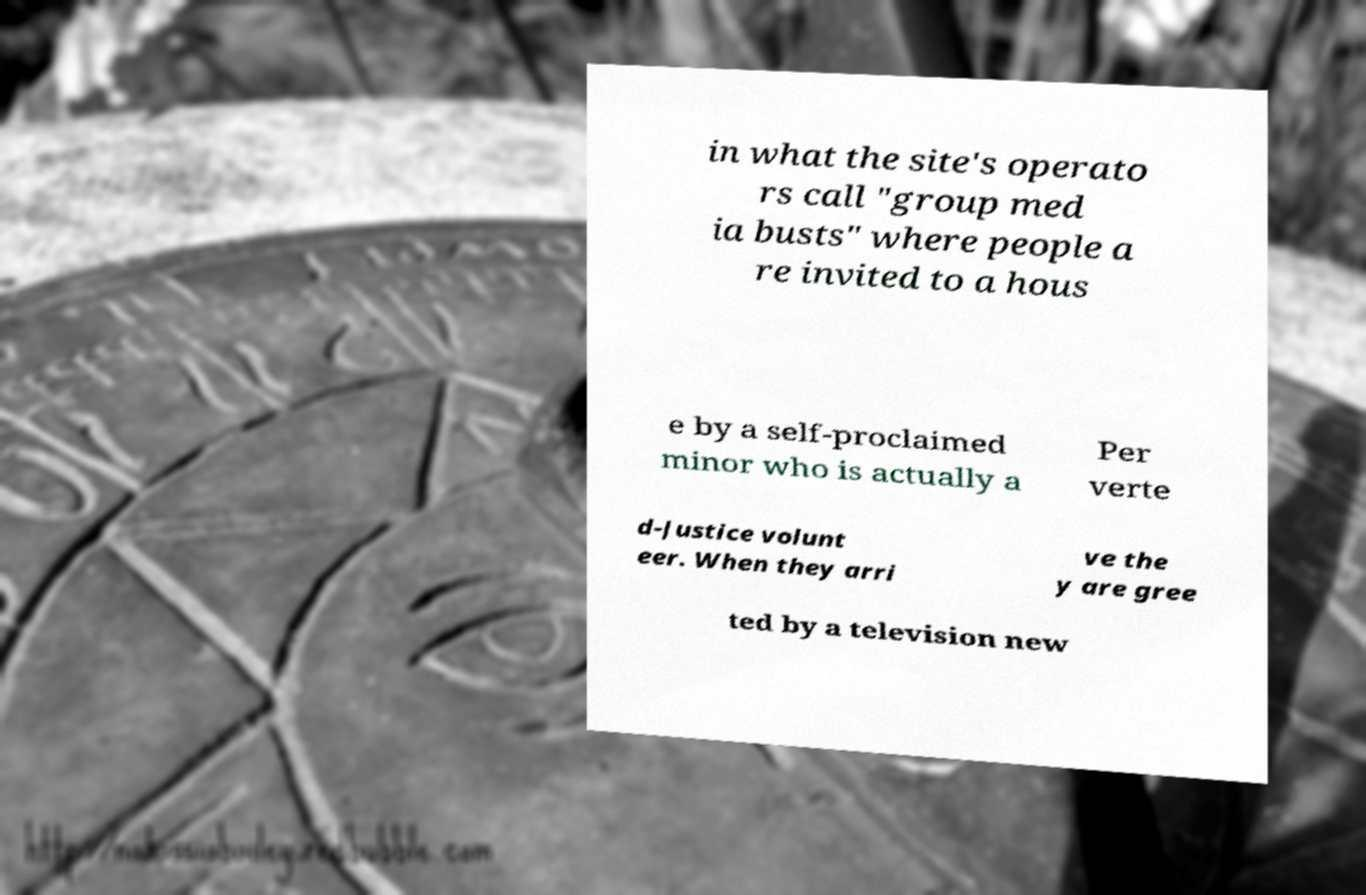I need the written content from this picture converted into text. Can you do that? in what the site's operato rs call "group med ia busts" where people a re invited to a hous e by a self-proclaimed minor who is actually a Per verte d-Justice volunt eer. When they arri ve the y are gree ted by a television new 